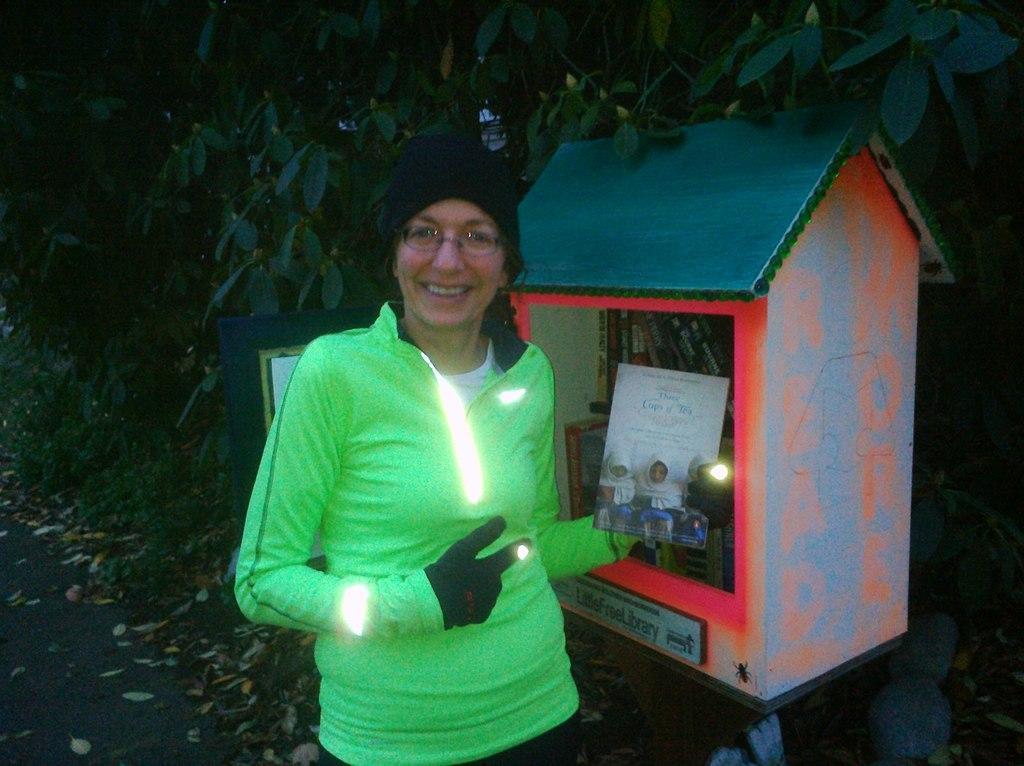Can you describe this image briefly? In the center of the image we can see a lady is standing and smiling and holding a book. In the background of the image we can see the trees, board, machine and lights. At the bottom of the image we can see the road and dry leaves. 